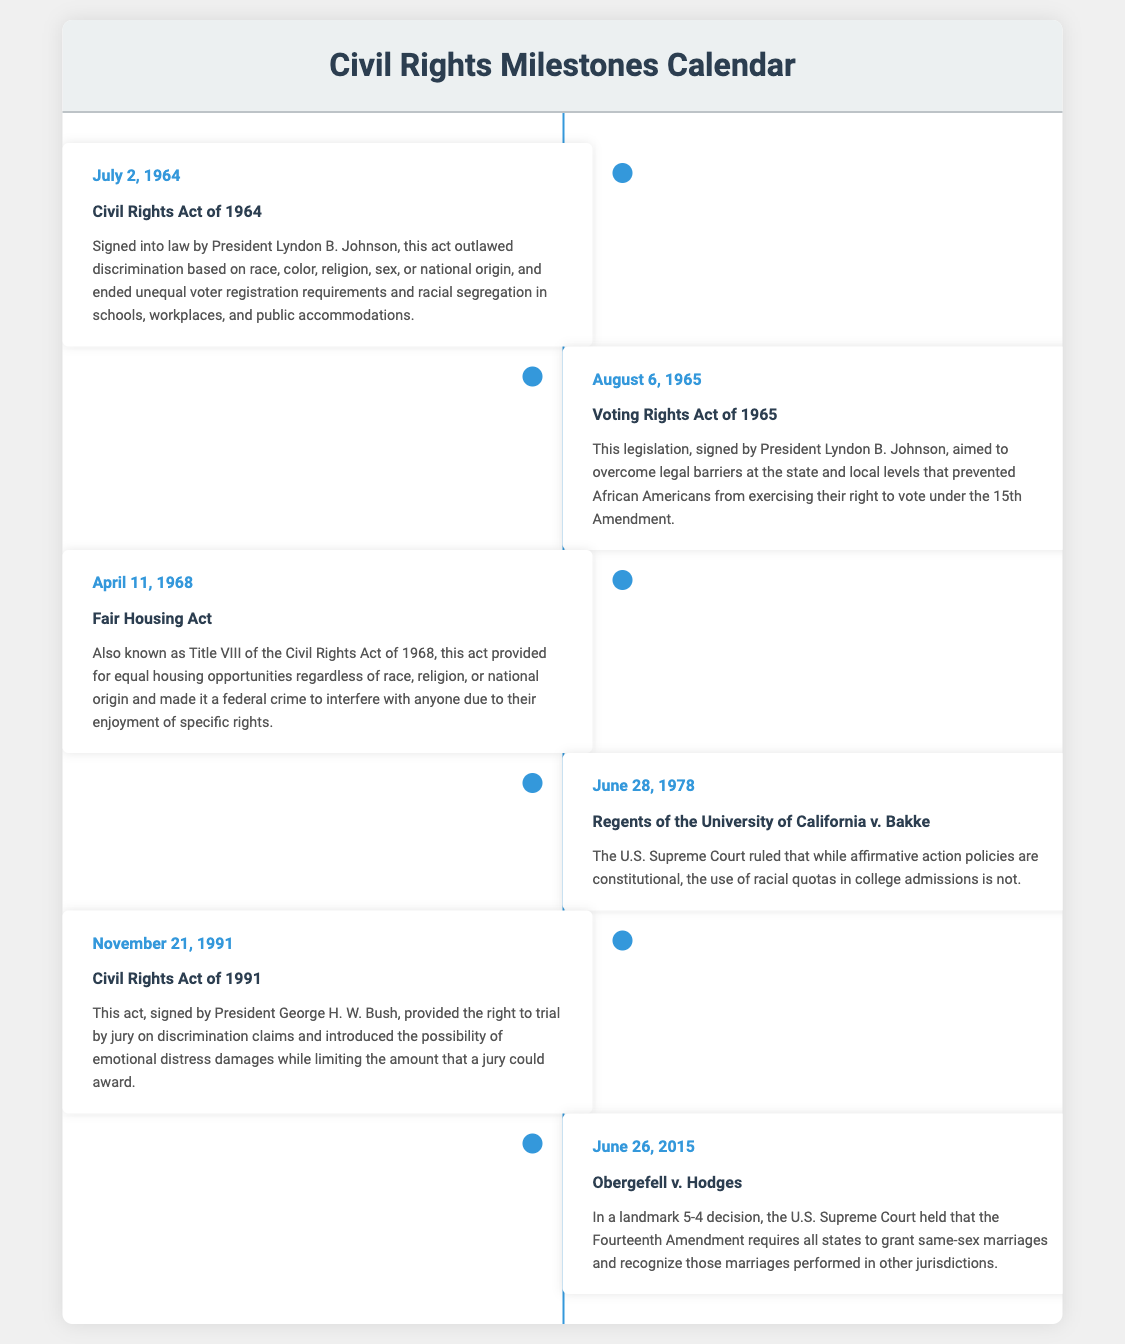What is the date of the Civil Rights Act? The document states that the Civil Rights Act was signed into law on July 2, 1964.
Answer: July 2, 1964 Who signed the Voting Rights Act into law? According to the document, the Voting Rights Act was signed by President Lyndon B. Johnson.
Answer: President Lyndon B. Johnson What does the Fair Housing Act ensure? The document notes that the Fair Housing Act provides equal housing opportunities regardless of race, religion, or national origin.
Answer: Equal housing opportunities When was the Civil Rights Act of 1991 enacted? The document indicates that the Civil Rights Act of 1991 was enacted on November 21, 1991.
Answer: November 21, 1991 What was the ruling in Regents of the University of California v. Bakke? The document describes that the ruling was that racial quotas in college admissions are not constitutional.
Answer: Not constitutional Which amendment was cited in the Obergefell v. Hodges case? The document mentions that the Fourteenth Amendment was cited in the Obergefell v. Hodges case.
Answer: Fourteenth Amendment What significant change did the Civil Rights Act of 1964 create? The document explains that the Civil Rights Act of 1964 outlawed discrimination based on several factors, creating significant legal protections.
Answer: Outlawed discrimination How many days after the Civil Rights Act of 1964 was the Voting Rights Act signed? The document shows the Civil Rights Act was signed on July 2, 1964, and the Voting Rights Act on August 6, 1965, which is 1 year and 35 days later.
Answer: 1 year and 35 days What major legal topic do the events in this document cover? The events outlined in the document address civil rights legislation and significant Supreme Court rulings related to civil rights.
Answer: Civil rights legislation 